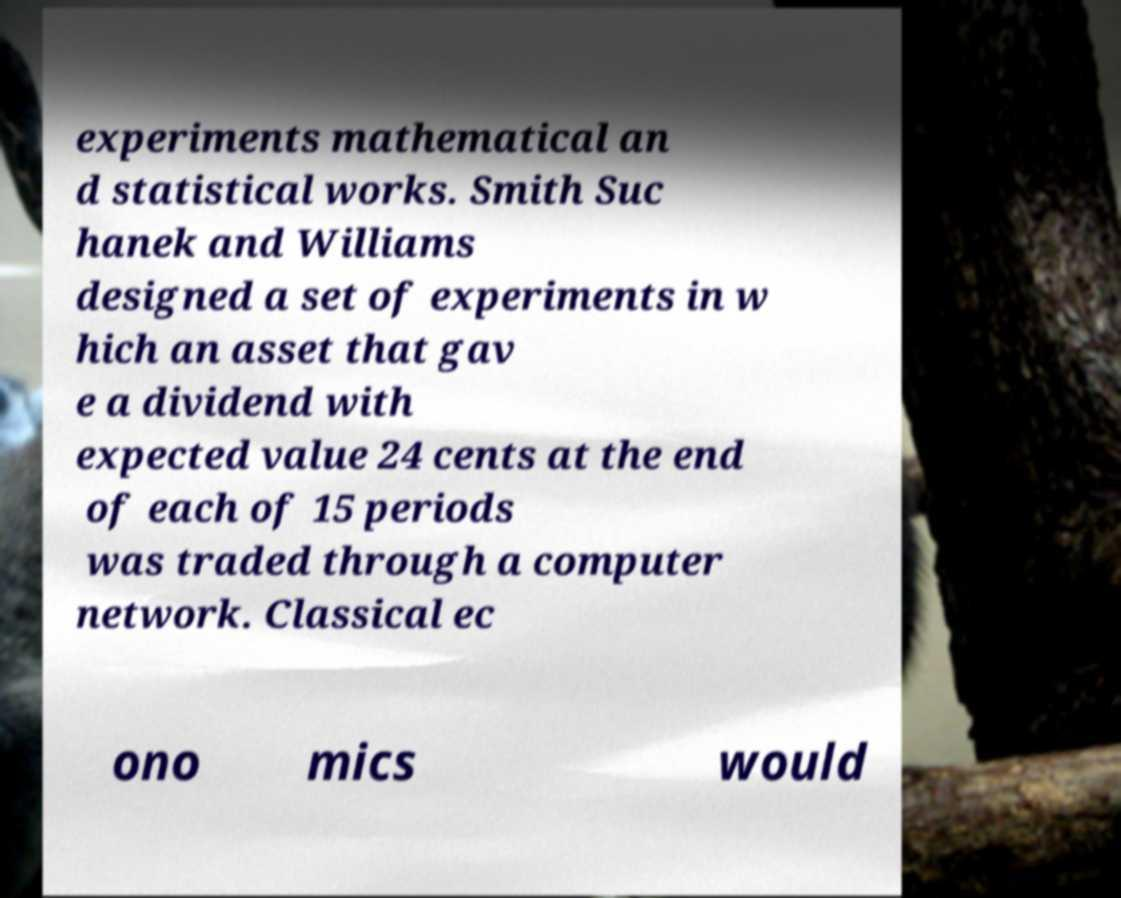Can you accurately transcribe the text from the provided image for me? experiments mathematical an d statistical works. Smith Suc hanek and Williams designed a set of experiments in w hich an asset that gav e a dividend with expected value 24 cents at the end of each of 15 periods was traded through a computer network. Classical ec ono mics would 